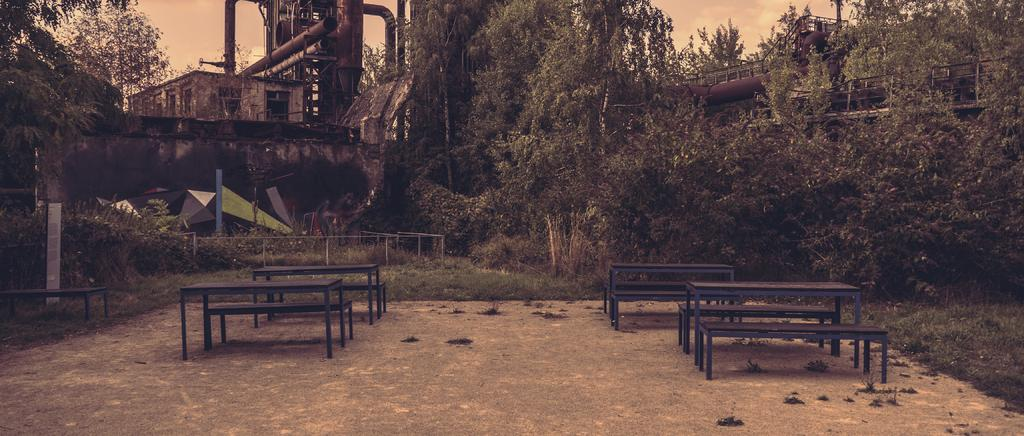What type of furniture can be seen in the image? There are tables and benches in the image. Where are the tables and benches located? The tables and benches are on a path in the image. What type of vegetation is visible in the image? There is grass and trees visible in the image. What type of structure is present in the image? There is a building in the image. What other objects can be seen in the image? Other objects present in the image include railings, pipes, and additional unspecified items. What is visible in the sky in the image? The sky is visible in the image. How many babies are crawling on the grass in the image? There are no babies present in the image; it features tables, benches, a path, grass, trees, a building, railings, pipes, and other unspecified objects. What type of plot does the building in the image belong to? The provided facts do not specify the type of plot or building in the image. 